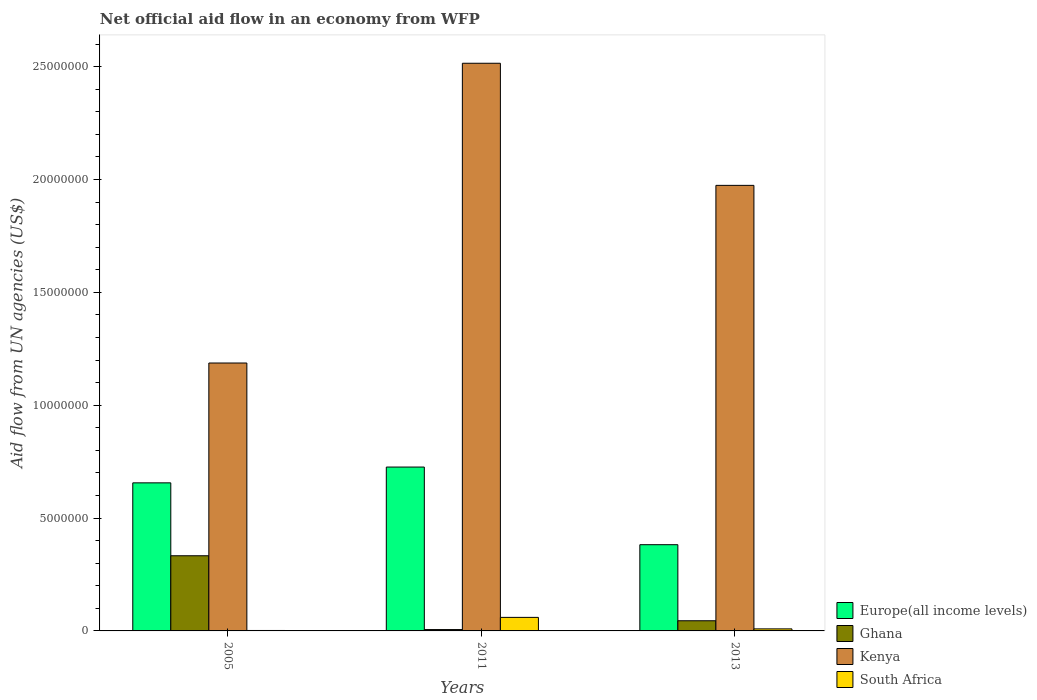How many groups of bars are there?
Provide a short and direct response. 3. Are the number of bars per tick equal to the number of legend labels?
Provide a succinct answer. Yes. Across all years, what is the maximum net official aid flow in Ghana?
Your answer should be very brief. 3.33e+06. Across all years, what is the minimum net official aid flow in South Africa?
Give a very brief answer. 2.00e+04. In which year was the net official aid flow in South Africa maximum?
Your response must be concise. 2011. In which year was the net official aid flow in Kenya minimum?
Provide a short and direct response. 2005. What is the total net official aid flow in Ghana in the graph?
Offer a terse response. 3.84e+06. What is the difference between the net official aid flow in Ghana in 2005 and that in 2013?
Your answer should be compact. 2.88e+06. What is the difference between the net official aid flow in Europe(all income levels) in 2011 and the net official aid flow in South Africa in 2005?
Provide a succinct answer. 7.24e+06. What is the average net official aid flow in Kenya per year?
Make the answer very short. 1.89e+07. In the year 2013, what is the difference between the net official aid flow in Ghana and net official aid flow in Kenya?
Offer a terse response. -1.93e+07. In how many years, is the net official aid flow in Ghana greater than 21000000 US$?
Provide a succinct answer. 0. What is the ratio of the net official aid flow in Europe(all income levels) in 2005 to that in 2011?
Your answer should be very brief. 0.9. Is the difference between the net official aid flow in Ghana in 2011 and 2013 greater than the difference between the net official aid flow in Kenya in 2011 and 2013?
Ensure brevity in your answer.  No. What is the difference between the highest and the second highest net official aid flow in Ghana?
Keep it short and to the point. 2.88e+06. What is the difference between the highest and the lowest net official aid flow in Kenya?
Keep it short and to the point. 1.33e+07. In how many years, is the net official aid flow in Kenya greater than the average net official aid flow in Kenya taken over all years?
Ensure brevity in your answer.  2. Is it the case that in every year, the sum of the net official aid flow in Ghana and net official aid flow in Kenya is greater than the sum of net official aid flow in Europe(all income levels) and net official aid flow in South Africa?
Your answer should be very brief. No. What does the 3rd bar from the left in 2013 represents?
Make the answer very short. Kenya. What does the 4th bar from the right in 2013 represents?
Provide a succinct answer. Europe(all income levels). How many bars are there?
Offer a terse response. 12. How many years are there in the graph?
Offer a very short reply. 3. Does the graph contain grids?
Offer a terse response. No. What is the title of the graph?
Offer a very short reply. Net official aid flow in an economy from WFP. What is the label or title of the Y-axis?
Your answer should be compact. Aid flow from UN agencies (US$). What is the Aid flow from UN agencies (US$) in Europe(all income levels) in 2005?
Give a very brief answer. 6.56e+06. What is the Aid flow from UN agencies (US$) of Ghana in 2005?
Your response must be concise. 3.33e+06. What is the Aid flow from UN agencies (US$) in Kenya in 2005?
Your response must be concise. 1.19e+07. What is the Aid flow from UN agencies (US$) in South Africa in 2005?
Provide a succinct answer. 2.00e+04. What is the Aid flow from UN agencies (US$) in Europe(all income levels) in 2011?
Offer a terse response. 7.26e+06. What is the Aid flow from UN agencies (US$) in Ghana in 2011?
Your response must be concise. 6.00e+04. What is the Aid flow from UN agencies (US$) of Kenya in 2011?
Offer a terse response. 2.52e+07. What is the Aid flow from UN agencies (US$) of Europe(all income levels) in 2013?
Provide a short and direct response. 3.82e+06. What is the Aid flow from UN agencies (US$) of Kenya in 2013?
Your answer should be compact. 1.97e+07. Across all years, what is the maximum Aid flow from UN agencies (US$) in Europe(all income levels)?
Provide a succinct answer. 7.26e+06. Across all years, what is the maximum Aid flow from UN agencies (US$) of Ghana?
Keep it short and to the point. 3.33e+06. Across all years, what is the maximum Aid flow from UN agencies (US$) in Kenya?
Your answer should be compact. 2.52e+07. Across all years, what is the maximum Aid flow from UN agencies (US$) of South Africa?
Provide a succinct answer. 6.00e+05. Across all years, what is the minimum Aid flow from UN agencies (US$) in Europe(all income levels)?
Make the answer very short. 3.82e+06. Across all years, what is the minimum Aid flow from UN agencies (US$) of Ghana?
Offer a terse response. 6.00e+04. Across all years, what is the minimum Aid flow from UN agencies (US$) of Kenya?
Give a very brief answer. 1.19e+07. What is the total Aid flow from UN agencies (US$) in Europe(all income levels) in the graph?
Provide a short and direct response. 1.76e+07. What is the total Aid flow from UN agencies (US$) of Ghana in the graph?
Your answer should be compact. 3.84e+06. What is the total Aid flow from UN agencies (US$) in Kenya in the graph?
Make the answer very short. 5.68e+07. What is the total Aid flow from UN agencies (US$) in South Africa in the graph?
Ensure brevity in your answer.  7.10e+05. What is the difference between the Aid flow from UN agencies (US$) in Europe(all income levels) in 2005 and that in 2011?
Your response must be concise. -7.00e+05. What is the difference between the Aid flow from UN agencies (US$) in Ghana in 2005 and that in 2011?
Your answer should be compact. 3.27e+06. What is the difference between the Aid flow from UN agencies (US$) of Kenya in 2005 and that in 2011?
Offer a terse response. -1.33e+07. What is the difference between the Aid flow from UN agencies (US$) in South Africa in 2005 and that in 2011?
Provide a succinct answer. -5.80e+05. What is the difference between the Aid flow from UN agencies (US$) of Europe(all income levels) in 2005 and that in 2013?
Make the answer very short. 2.74e+06. What is the difference between the Aid flow from UN agencies (US$) in Ghana in 2005 and that in 2013?
Offer a terse response. 2.88e+06. What is the difference between the Aid flow from UN agencies (US$) in Kenya in 2005 and that in 2013?
Your answer should be compact. -7.87e+06. What is the difference between the Aid flow from UN agencies (US$) of Europe(all income levels) in 2011 and that in 2013?
Make the answer very short. 3.44e+06. What is the difference between the Aid flow from UN agencies (US$) of Ghana in 2011 and that in 2013?
Keep it short and to the point. -3.90e+05. What is the difference between the Aid flow from UN agencies (US$) of Kenya in 2011 and that in 2013?
Offer a terse response. 5.41e+06. What is the difference between the Aid flow from UN agencies (US$) of South Africa in 2011 and that in 2013?
Your response must be concise. 5.10e+05. What is the difference between the Aid flow from UN agencies (US$) in Europe(all income levels) in 2005 and the Aid flow from UN agencies (US$) in Ghana in 2011?
Your response must be concise. 6.50e+06. What is the difference between the Aid flow from UN agencies (US$) in Europe(all income levels) in 2005 and the Aid flow from UN agencies (US$) in Kenya in 2011?
Provide a succinct answer. -1.86e+07. What is the difference between the Aid flow from UN agencies (US$) of Europe(all income levels) in 2005 and the Aid flow from UN agencies (US$) of South Africa in 2011?
Offer a terse response. 5.96e+06. What is the difference between the Aid flow from UN agencies (US$) of Ghana in 2005 and the Aid flow from UN agencies (US$) of Kenya in 2011?
Offer a terse response. -2.18e+07. What is the difference between the Aid flow from UN agencies (US$) of Ghana in 2005 and the Aid flow from UN agencies (US$) of South Africa in 2011?
Make the answer very short. 2.73e+06. What is the difference between the Aid flow from UN agencies (US$) of Kenya in 2005 and the Aid flow from UN agencies (US$) of South Africa in 2011?
Provide a succinct answer. 1.13e+07. What is the difference between the Aid flow from UN agencies (US$) in Europe(all income levels) in 2005 and the Aid flow from UN agencies (US$) in Ghana in 2013?
Your response must be concise. 6.11e+06. What is the difference between the Aid flow from UN agencies (US$) of Europe(all income levels) in 2005 and the Aid flow from UN agencies (US$) of Kenya in 2013?
Ensure brevity in your answer.  -1.32e+07. What is the difference between the Aid flow from UN agencies (US$) of Europe(all income levels) in 2005 and the Aid flow from UN agencies (US$) of South Africa in 2013?
Make the answer very short. 6.47e+06. What is the difference between the Aid flow from UN agencies (US$) in Ghana in 2005 and the Aid flow from UN agencies (US$) in Kenya in 2013?
Keep it short and to the point. -1.64e+07. What is the difference between the Aid flow from UN agencies (US$) in Ghana in 2005 and the Aid flow from UN agencies (US$) in South Africa in 2013?
Your answer should be very brief. 3.24e+06. What is the difference between the Aid flow from UN agencies (US$) of Kenya in 2005 and the Aid flow from UN agencies (US$) of South Africa in 2013?
Ensure brevity in your answer.  1.18e+07. What is the difference between the Aid flow from UN agencies (US$) in Europe(all income levels) in 2011 and the Aid flow from UN agencies (US$) in Ghana in 2013?
Offer a terse response. 6.81e+06. What is the difference between the Aid flow from UN agencies (US$) in Europe(all income levels) in 2011 and the Aid flow from UN agencies (US$) in Kenya in 2013?
Offer a very short reply. -1.25e+07. What is the difference between the Aid flow from UN agencies (US$) in Europe(all income levels) in 2011 and the Aid flow from UN agencies (US$) in South Africa in 2013?
Your response must be concise. 7.17e+06. What is the difference between the Aid flow from UN agencies (US$) in Ghana in 2011 and the Aid flow from UN agencies (US$) in Kenya in 2013?
Your answer should be very brief. -1.97e+07. What is the difference between the Aid flow from UN agencies (US$) of Ghana in 2011 and the Aid flow from UN agencies (US$) of South Africa in 2013?
Your answer should be compact. -3.00e+04. What is the difference between the Aid flow from UN agencies (US$) of Kenya in 2011 and the Aid flow from UN agencies (US$) of South Africa in 2013?
Provide a succinct answer. 2.51e+07. What is the average Aid flow from UN agencies (US$) in Europe(all income levels) per year?
Ensure brevity in your answer.  5.88e+06. What is the average Aid flow from UN agencies (US$) of Ghana per year?
Offer a terse response. 1.28e+06. What is the average Aid flow from UN agencies (US$) of Kenya per year?
Give a very brief answer. 1.89e+07. What is the average Aid flow from UN agencies (US$) in South Africa per year?
Provide a short and direct response. 2.37e+05. In the year 2005, what is the difference between the Aid flow from UN agencies (US$) of Europe(all income levels) and Aid flow from UN agencies (US$) of Ghana?
Make the answer very short. 3.23e+06. In the year 2005, what is the difference between the Aid flow from UN agencies (US$) of Europe(all income levels) and Aid flow from UN agencies (US$) of Kenya?
Provide a succinct answer. -5.31e+06. In the year 2005, what is the difference between the Aid flow from UN agencies (US$) of Europe(all income levels) and Aid flow from UN agencies (US$) of South Africa?
Make the answer very short. 6.54e+06. In the year 2005, what is the difference between the Aid flow from UN agencies (US$) in Ghana and Aid flow from UN agencies (US$) in Kenya?
Offer a terse response. -8.54e+06. In the year 2005, what is the difference between the Aid flow from UN agencies (US$) in Ghana and Aid flow from UN agencies (US$) in South Africa?
Give a very brief answer. 3.31e+06. In the year 2005, what is the difference between the Aid flow from UN agencies (US$) of Kenya and Aid flow from UN agencies (US$) of South Africa?
Ensure brevity in your answer.  1.18e+07. In the year 2011, what is the difference between the Aid flow from UN agencies (US$) of Europe(all income levels) and Aid flow from UN agencies (US$) of Ghana?
Keep it short and to the point. 7.20e+06. In the year 2011, what is the difference between the Aid flow from UN agencies (US$) in Europe(all income levels) and Aid flow from UN agencies (US$) in Kenya?
Make the answer very short. -1.79e+07. In the year 2011, what is the difference between the Aid flow from UN agencies (US$) in Europe(all income levels) and Aid flow from UN agencies (US$) in South Africa?
Offer a terse response. 6.66e+06. In the year 2011, what is the difference between the Aid flow from UN agencies (US$) in Ghana and Aid flow from UN agencies (US$) in Kenya?
Keep it short and to the point. -2.51e+07. In the year 2011, what is the difference between the Aid flow from UN agencies (US$) in Ghana and Aid flow from UN agencies (US$) in South Africa?
Your answer should be very brief. -5.40e+05. In the year 2011, what is the difference between the Aid flow from UN agencies (US$) in Kenya and Aid flow from UN agencies (US$) in South Africa?
Your answer should be very brief. 2.46e+07. In the year 2013, what is the difference between the Aid flow from UN agencies (US$) in Europe(all income levels) and Aid flow from UN agencies (US$) in Ghana?
Provide a short and direct response. 3.37e+06. In the year 2013, what is the difference between the Aid flow from UN agencies (US$) in Europe(all income levels) and Aid flow from UN agencies (US$) in Kenya?
Offer a terse response. -1.59e+07. In the year 2013, what is the difference between the Aid flow from UN agencies (US$) of Europe(all income levels) and Aid flow from UN agencies (US$) of South Africa?
Your answer should be very brief. 3.73e+06. In the year 2013, what is the difference between the Aid flow from UN agencies (US$) of Ghana and Aid flow from UN agencies (US$) of Kenya?
Provide a succinct answer. -1.93e+07. In the year 2013, what is the difference between the Aid flow from UN agencies (US$) of Kenya and Aid flow from UN agencies (US$) of South Africa?
Provide a short and direct response. 1.96e+07. What is the ratio of the Aid flow from UN agencies (US$) of Europe(all income levels) in 2005 to that in 2011?
Ensure brevity in your answer.  0.9. What is the ratio of the Aid flow from UN agencies (US$) of Ghana in 2005 to that in 2011?
Provide a succinct answer. 55.5. What is the ratio of the Aid flow from UN agencies (US$) in Kenya in 2005 to that in 2011?
Provide a short and direct response. 0.47. What is the ratio of the Aid flow from UN agencies (US$) in South Africa in 2005 to that in 2011?
Provide a succinct answer. 0.03. What is the ratio of the Aid flow from UN agencies (US$) of Europe(all income levels) in 2005 to that in 2013?
Offer a terse response. 1.72. What is the ratio of the Aid flow from UN agencies (US$) of Kenya in 2005 to that in 2013?
Provide a succinct answer. 0.6. What is the ratio of the Aid flow from UN agencies (US$) of South Africa in 2005 to that in 2013?
Keep it short and to the point. 0.22. What is the ratio of the Aid flow from UN agencies (US$) in Europe(all income levels) in 2011 to that in 2013?
Make the answer very short. 1.9. What is the ratio of the Aid flow from UN agencies (US$) of Ghana in 2011 to that in 2013?
Provide a short and direct response. 0.13. What is the ratio of the Aid flow from UN agencies (US$) in Kenya in 2011 to that in 2013?
Your answer should be compact. 1.27. What is the ratio of the Aid flow from UN agencies (US$) in South Africa in 2011 to that in 2013?
Offer a very short reply. 6.67. What is the difference between the highest and the second highest Aid flow from UN agencies (US$) of Ghana?
Offer a very short reply. 2.88e+06. What is the difference between the highest and the second highest Aid flow from UN agencies (US$) of Kenya?
Make the answer very short. 5.41e+06. What is the difference between the highest and the second highest Aid flow from UN agencies (US$) of South Africa?
Offer a very short reply. 5.10e+05. What is the difference between the highest and the lowest Aid flow from UN agencies (US$) of Europe(all income levels)?
Ensure brevity in your answer.  3.44e+06. What is the difference between the highest and the lowest Aid flow from UN agencies (US$) in Ghana?
Your answer should be compact. 3.27e+06. What is the difference between the highest and the lowest Aid flow from UN agencies (US$) in Kenya?
Your response must be concise. 1.33e+07. What is the difference between the highest and the lowest Aid flow from UN agencies (US$) in South Africa?
Keep it short and to the point. 5.80e+05. 